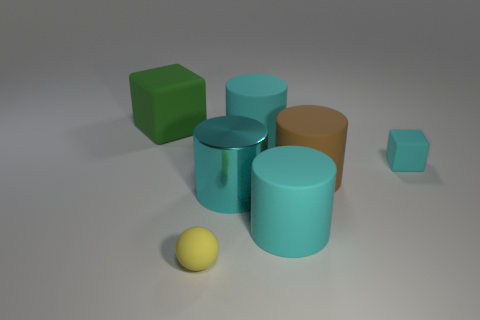Subtract all big brown matte cylinders. How many cylinders are left? 3 Subtract all red spheres. How many cyan cylinders are left? 3 Subtract all cyan cylinders. How many cylinders are left? 1 Subtract all cylinders. How many objects are left? 3 Subtract 1 cylinders. How many cylinders are left? 3 Add 1 yellow matte spheres. How many objects exist? 8 Subtract all small yellow metallic cylinders. Subtract all big matte cylinders. How many objects are left? 4 Add 1 rubber things. How many rubber things are left? 7 Add 1 large green matte cubes. How many large green matte cubes exist? 2 Subtract 0 purple cylinders. How many objects are left? 7 